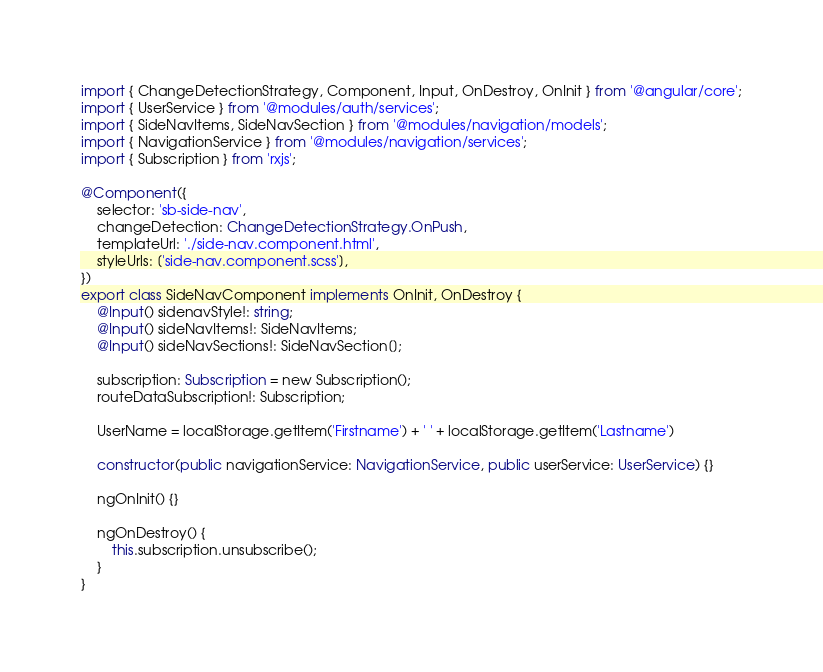<code> <loc_0><loc_0><loc_500><loc_500><_TypeScript_>import { ChangeDetectionStrategy, Component, Input, OnDestroy, OnInit } from '@angular/core';
import { UserService } from '@modules/auth/services';
import { SideNavItems, SideNavSection } from '@modules/navigation/models';
import { NavigationService } from '@modules/navigation/services';
import { Subscription } from 'rxjs';

@Component({
    selector: 'sb-side-nav',
    changeDetection: ChangeDetectionStrategy.OnPush,
    templateUrl: './side-nav.component.html',
    styleUrls: ['side-nav.component.scss'],
})
export class SideNavComponent implements OnInit, OnDestroy {
    @Input() sidenavStyle!: string;
    @Input() sideNavItems!: SideNavItems;
    @Input() sideNavSections!: SideNavSection[];

    subscription: Subscription = new Subscription();
    routeDataSubscription!: Subscription;

    UserName = localStorage.getItem('Firstname') + ' ' + localStorage.getItem('Lastname')

    constructor(public navigationService: NavigationService, public userService: UserService) {}

    ngOnInit() {}

    ngOnDestroy() {
        this.subscription.unsubscribe();
    }
}
</code> 